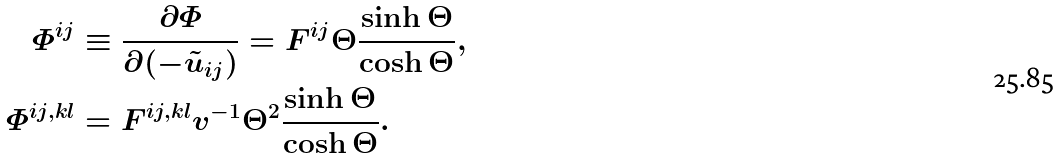Convert formula to latex. <formula><loc_0><loc_0><loc_500><loc_500>\varPhi ^ { i j } & \equiv \frac { \partial \varPhi } { \partial ( - \tilde { u } _ { i j } ) } = F ^ { i j } \Theta \frac { \sinh \Theta } { \cosh \Theta } , \\ \varPhi ^ { i j , k l } & = F ^ { i j , k l } v ^ { - 1 } \Theta ^ { 2 } \frac { \sinh \Theta } { \cosh \Theta } .</formula> 